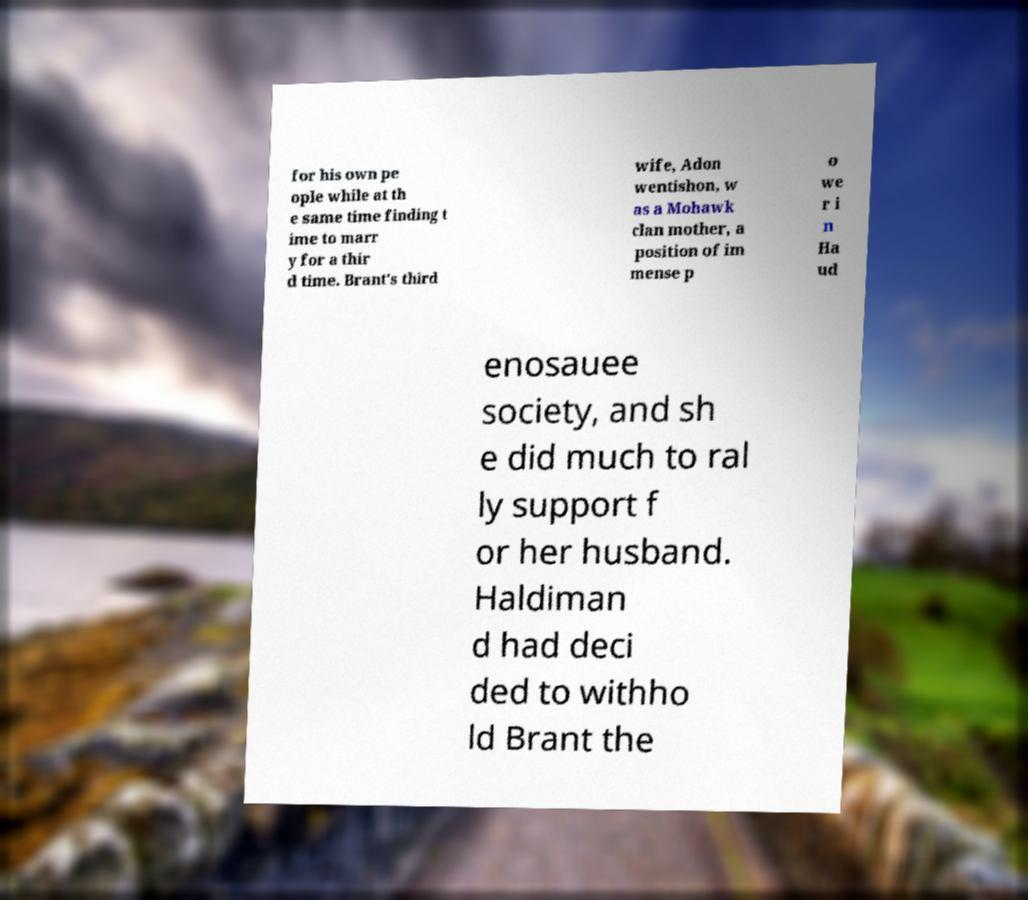Please identify and transcribe the text found in this image. for his own pe ople while at th e same time finding t ime to marr y for a thir d time. Brant's third wife, Adon wentishon, w as a Mohawk clan mother, a position of im mense p o we r i n Ha ud enosauee society, and sh e did much to ral ly support f or her husband. Haldiman d had deci ded to withho ld Brant the 